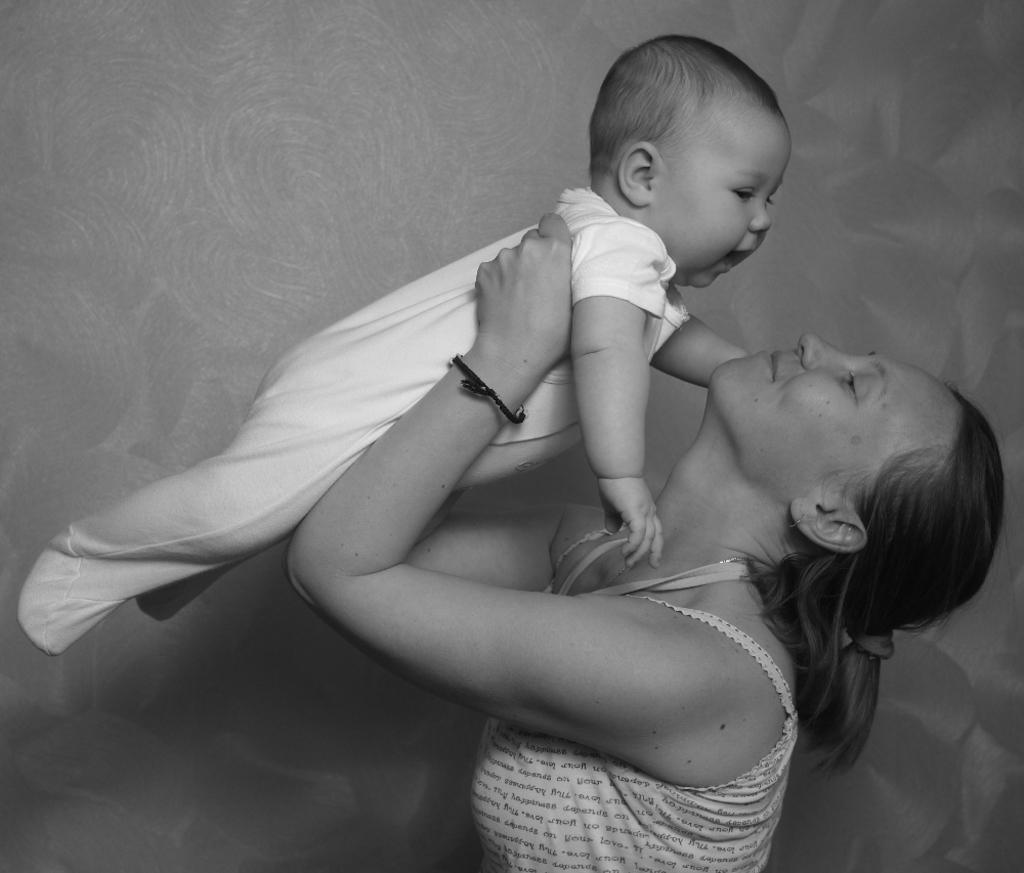What is the color scheme of the image? The image is black and white. Who is present in the image? There is a lady and a baby in the image. What can be seen in the background of the image? There is a wall in the background of the image. What type of rhythm can be heard in the image? There is no sound or rhythm present in the image, as it is a still photograph. 